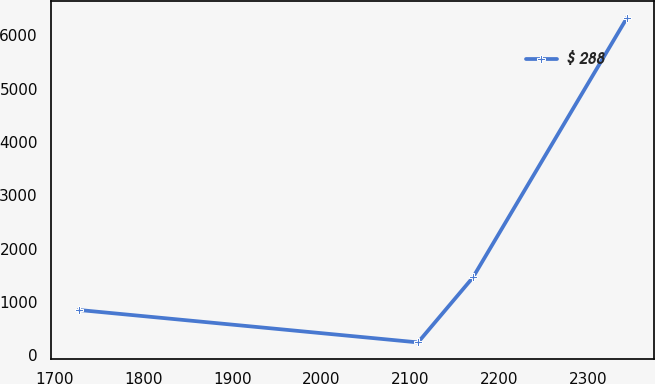<chart> <loc_0><loc_0><loc_500><loc_500><line_chart><ecel><fcel>$ 288<nl><fcel>1727.49<fcel>851.32<nl><fcel>2108.8<fcel>242.31<nl><fcel>2170.4<fcel>1460.33<nl><fcel>2343.53<fcel>6332.36<nl></chart> 